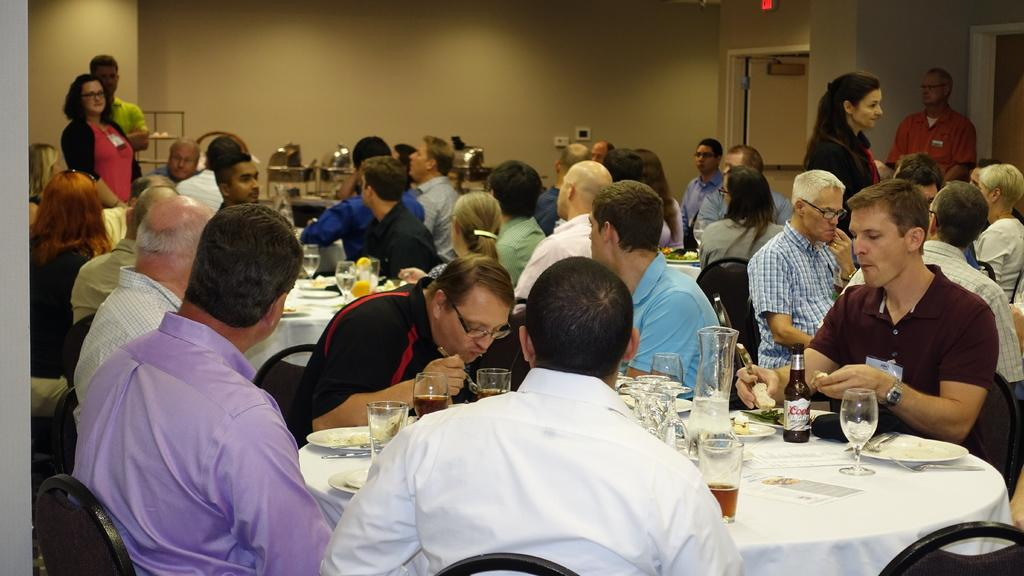What are the people in the image doing? There is a group of people sitting in front of a table, which suggests they might be eating or socializing. What can be found on the table? There are eatables and drinks on the table. Are there any other people in the image besides those sitting at the table? Yes, there are two persons standing in the left corner and two persons standing in the right corner. What type of seed is being planted by the bears in the image? There are no bears or seeds present in the image; it features a group of people sitting at a table with eatables and drinks. 